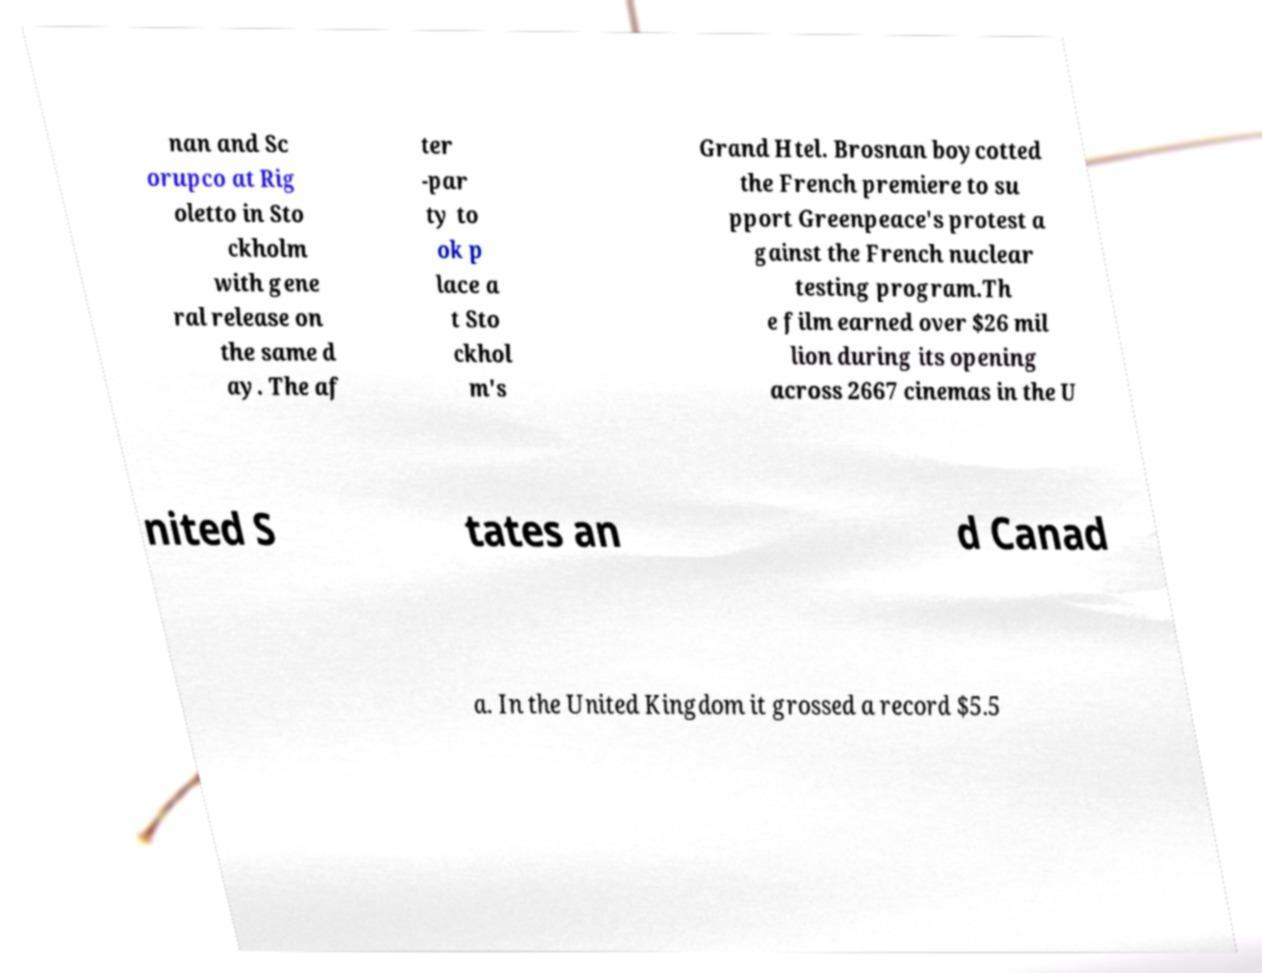Can you accurately transcribe the text from the provided image for me? nan and Sc orupco at Rig oletto in Sto ckholm with gene ral release on the same d ay. The af ter -par ty to ok p lace a t Sto ckhol m's Grand Htel. Brosnan boycotted the French premiere to su pport Greenpeace's protest a gainst the French nuclear testing program.Th e film earned over $26 mil lion during its opening across 2667 cinemas in the U nited S tates an d Canad a. In the United Kingdom it grossed a record $5.5 